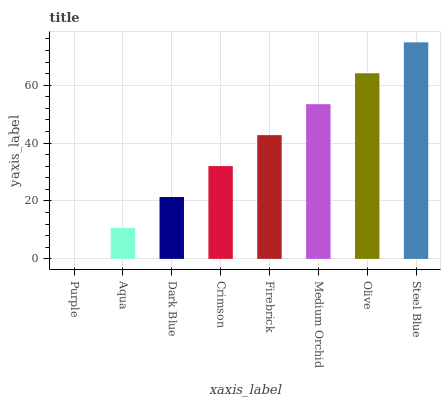Is Purple the minimum?
Answer yes or no. Yes. Is Steel Blue the maximum?
Answer yes or no. Yes. Is Aqua the minimum?
Answer yes or no. No. Is Aqua the maximum?
Answer yes or no. No. Is Aqua greater than Purple?
Answer yes or no. Yes. Is Purple less than Aqua?
Answer yes or no. Yes. Is Purple greater than Aqua?
Answer yes or no. No. Is Aqua less than Purple?
Answer yes or no. No. Is Firebrick the high median?
Answer yes or no. Yes. Is Crimson the low median?
Answer yes or no. Yes. Is Medium Orchid the high median?
Answer yes or no. No. Is Medium Orchid the low median?
Answer yes or no. No. 